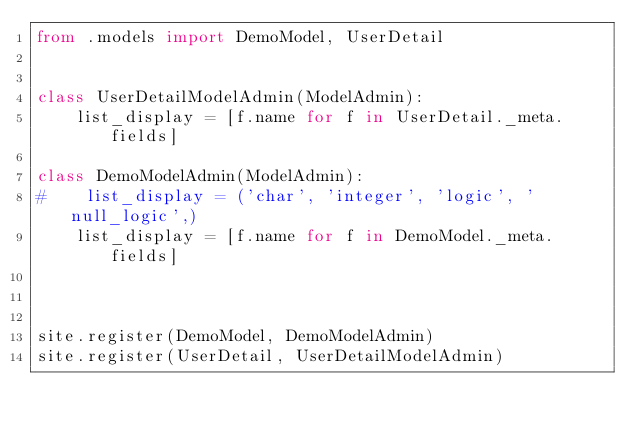<code> <loc_0><loc_0><loc_500><loc_500><_Python_>from .models import DemoModel, UserDetail


class UserDetailModelAdmin(ModelAdmin):
    list_display = [f.name for f in UserDetail._meta.fields]

class DemoModelAdmin(ModelAdmin):
#    list_display = ('char', 'integer', 'logic', 'null_logic',)
    list_display = [f.name for f in DemoModel._meta.fields]



site.register(DemoModel, DemoModelAdmin)
site.register(UserDetail, UserDetailModelAdmin)
</code> 